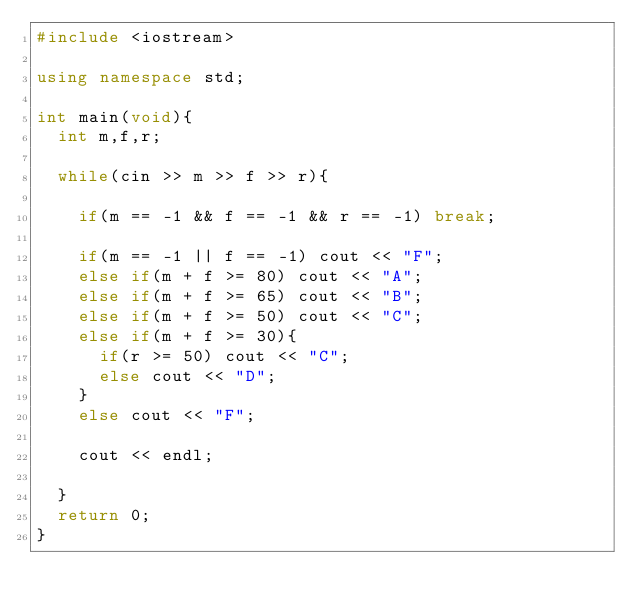<code> <loc_0><loc_0><loc_500><loc_500><_C++_>#include <iostream>

using namespace std;

int main(void){
  int m,f,r;

  while(cin >> m >> f >> r){
   
    if(m == -1 && f == -1 && r == -1) break;
    
    if(m == -1 || f == -1) cout << "F";
    else if(m + f >= 80) cout << "A";
    else if(m + f >= 65) cout << "B";
    else if(m + f >= 50) cout << "C";
    else if(m + f >= 30){
      if(r >= 50) cout << "C";
      else cout << "D";
    }
    else cout << "F";
    
    cout << endl;
    
  }
  return 0;
}</code> 